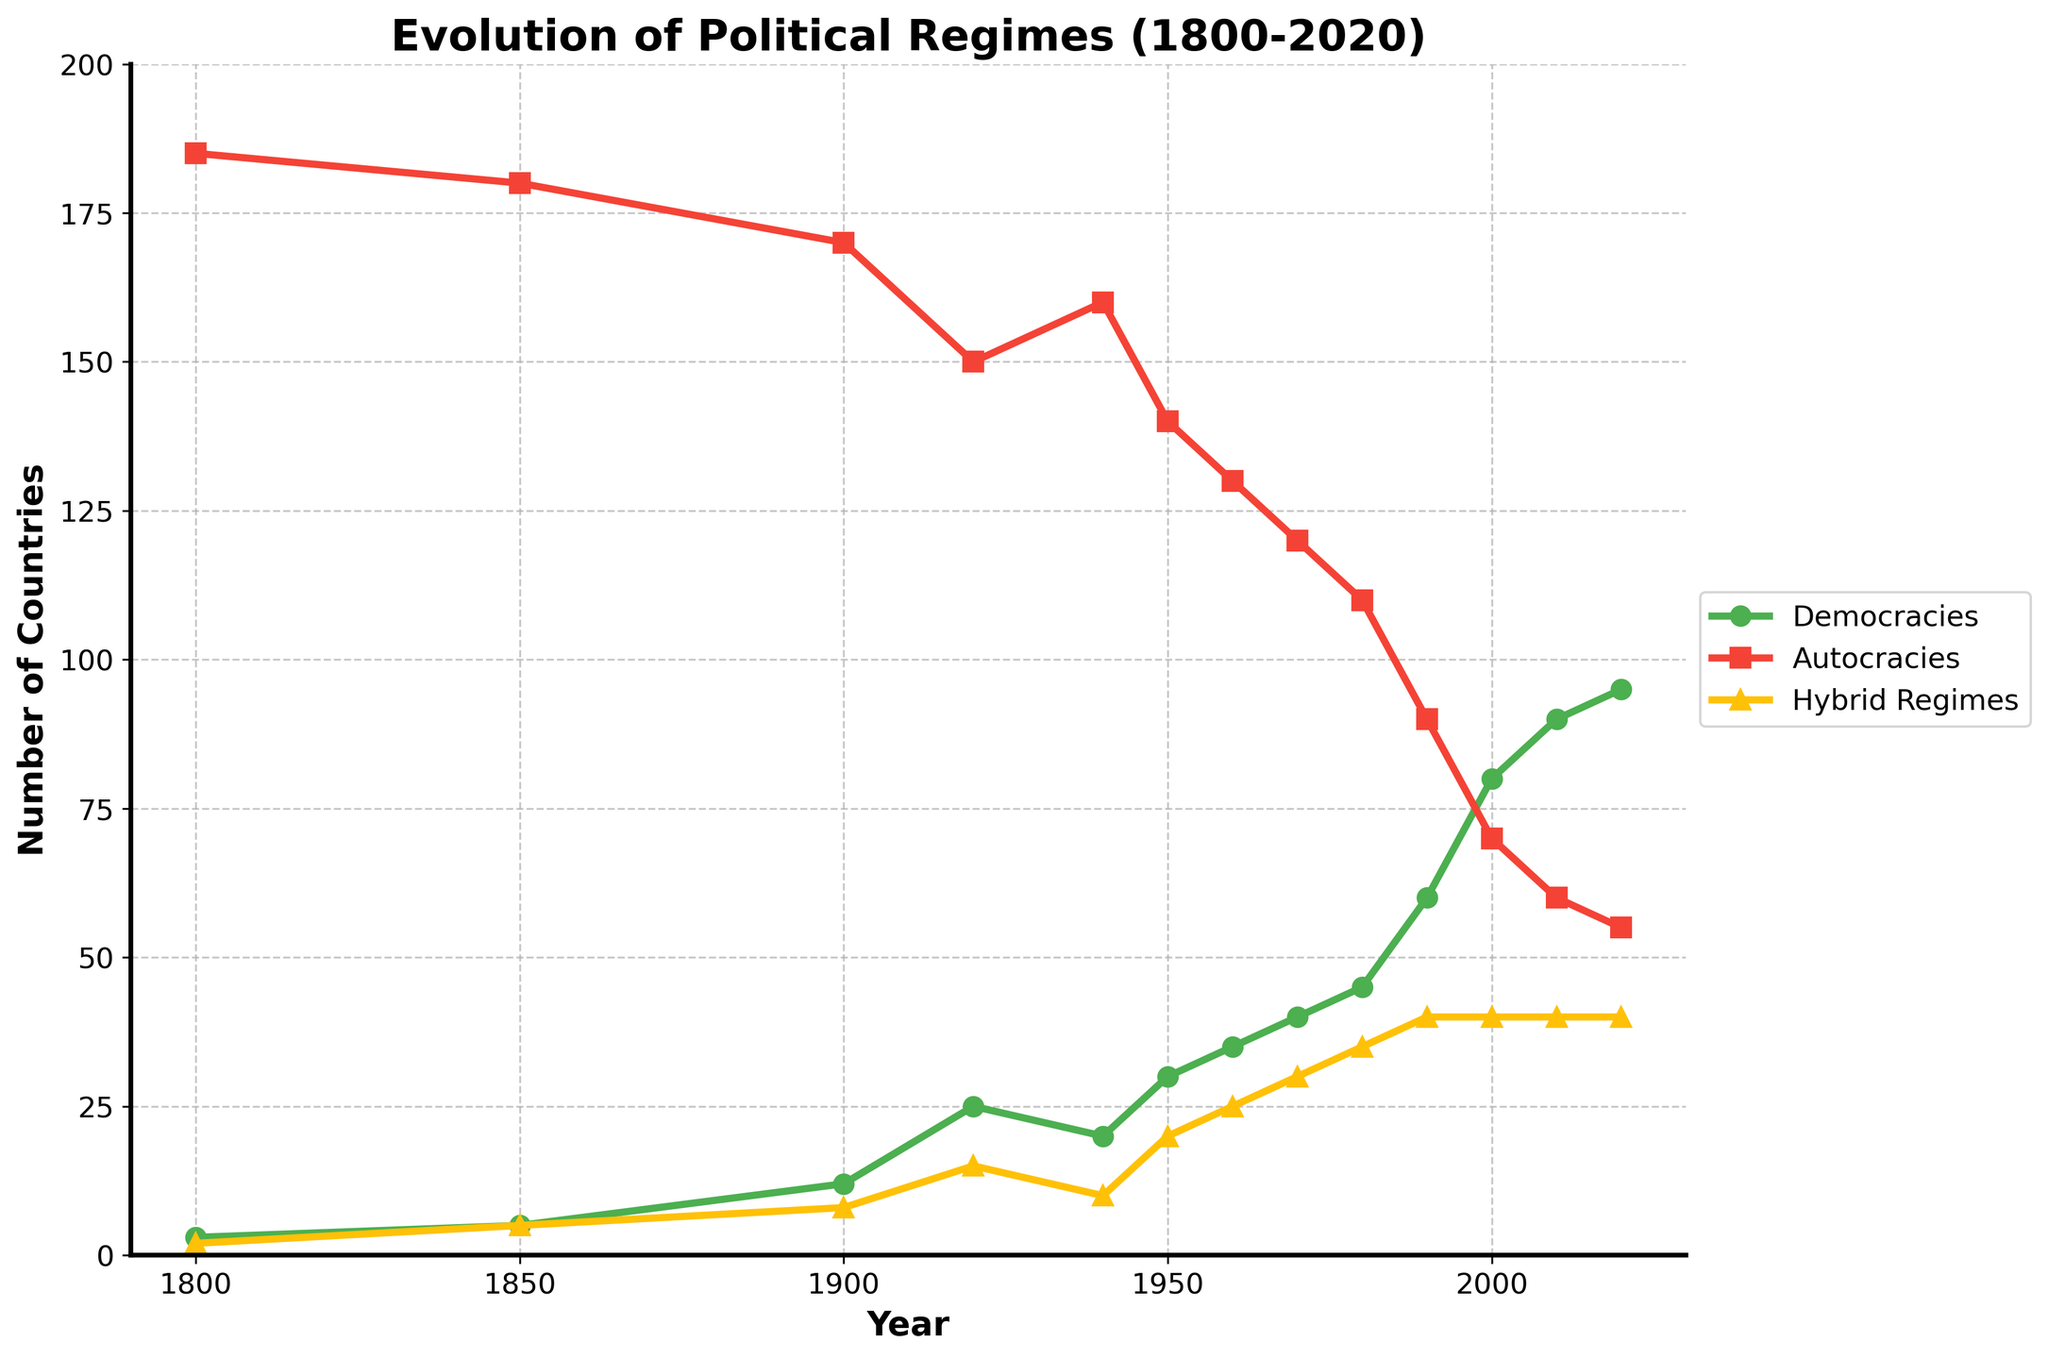Which year had the highest number of democracies? By examining the plot, the highest point on the green line, which represents democracies, is reached in 2020.
Answer: 2020 When did the number of autocracies first fall below 100? The red line representing autocracies dips below 100 for the first time around 1990.
Answer: 1990 How many more democracies were there in 2020 compared to 1900? In 1900, there were 12 democracies, and in 2020, there were 95. The difference is 95 - 12 = 83.
Answer: 83 Which regime type saw the most consistent increase over the entire period? By observing the trends, the green line (democracies) consistently rises throughout the timeline with minimal fluctuations compared to the other lines.
Answer: Democracies In which decade did hybrid regimes see the largest increase in number? The largest noticeable increase in the yellow line representing hybrid regimes appears between 1940 and 1950.
Answer: 1940s How many democracies were there in 1950 compared to autocracies in the same year? In 1950, the plot shows there were 30 democracies and 140 autocracies.
Answer: Democracies: 30, Autocracies: 140 Which type of regime was most predominant in 1800? In 1800, the red line (autocracies) is the highest, showing that autocracies were the most prevalent type.
Answer: Autocracies By how much did the number of hybrid regimes increase between 1920 and 1980? In 1920, there were 15 hybrid regimes, and in 1980, there were 35. The increase is 35 - 15 = 20.
Answer: 20 What is the trend for autocracies from 1900 to 2020? The plot shows a general decline in the number of autocracies from the peak in 1900 to a lower value in 2020.
Answer: Declining How did the number of democracies and autocracies compare in the year 2000? In 2000, the plot indicates there were 80 democracies and 70 autocracies.
Answer: Democracies: 80, Autocracies: 70 